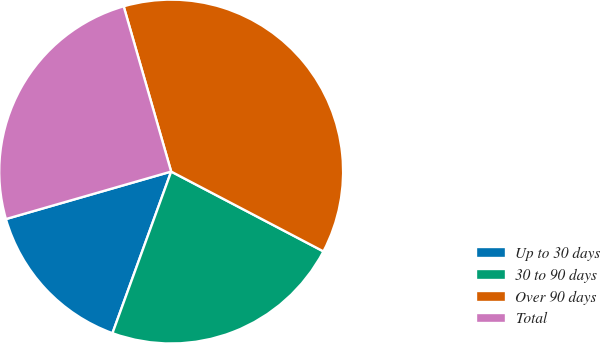Convert chart to OTSL. <chart><loc_0><loc_0><loc_500><loc_500><pie_chart><fcel>Up to 30 days<fcel>30 to 90 days<fcel>Over 90 days<fcel>Total<nl><fcel>15.0%<fcel>22.86%<fcel>37.14%<fcel>25.0%<nl></chart> 